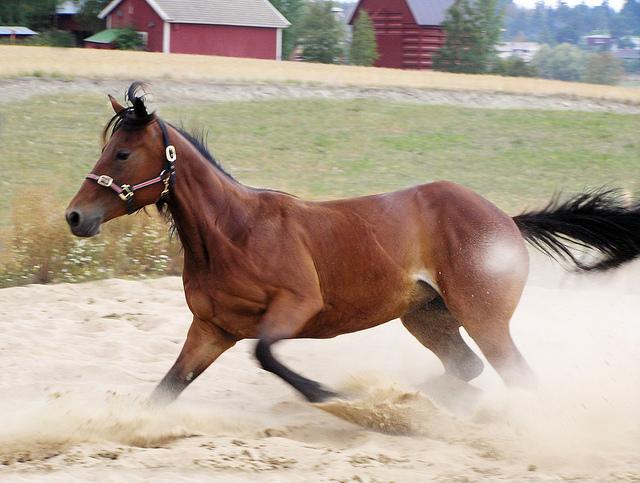Are there sheep in this picture?
Give a very brief answer. No. What color is the building in the background?
Answer briefly. Red. Is the horse sad?
Keep it brief. No. How many red buildings are there?
Keep it brief. 2. Is this horse barrel racing?
Be succinct. No. 